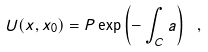<formula> <loc_0><loc_0><loc_500><loc_500>U ( x , x _ { 0 } ) = P \exp \left ( - \int _ { C } a \right ) \ ,</formula> 